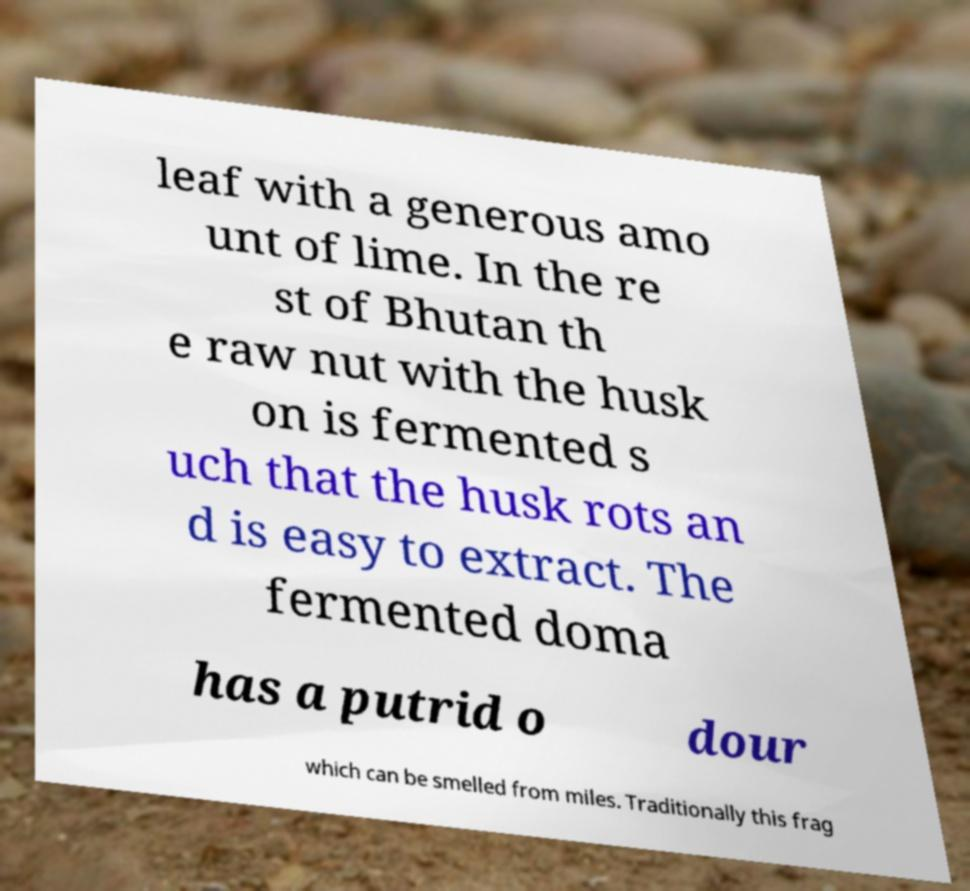Could you extract and type out the text from this image? leaf with a generous amo unt of lime. In the re st of Bhutan th e raw nut with the husk on is fermented s uch that the husk rots an d is easy to extract. The fermented doma has a putrid o dour which can be smelled from miles. Traditionally this frag 